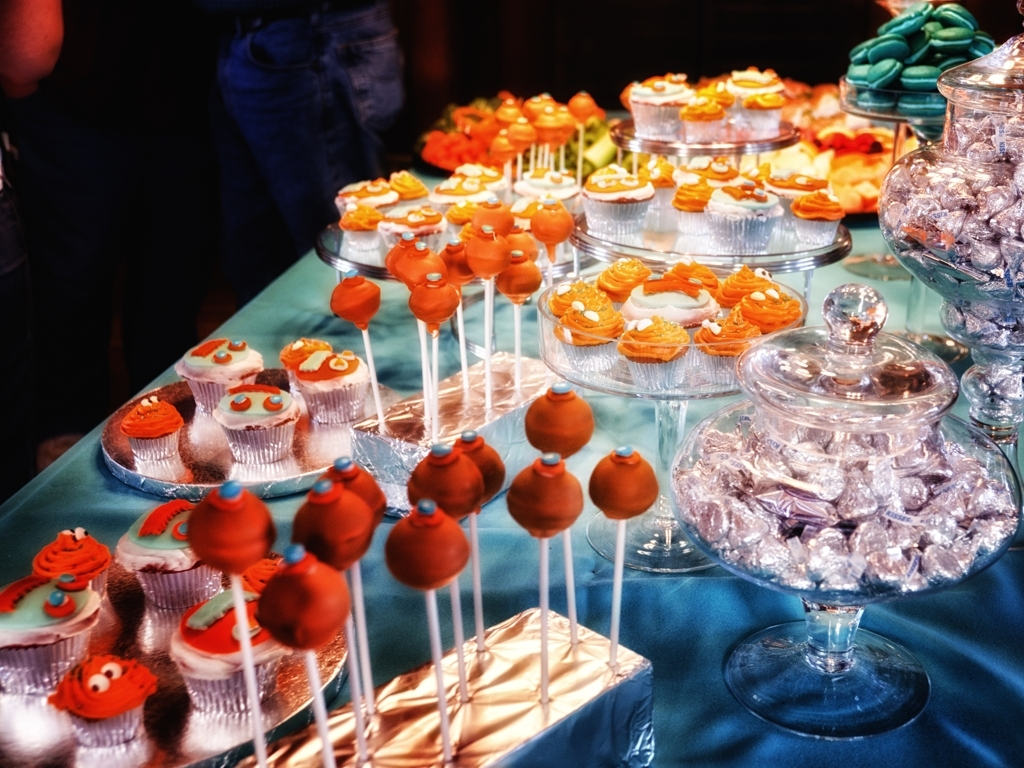What occasion might these treats be for? The display of festive cupcakes and cake pops, along with wrapped candies, suggests that these treats could be for a special celebration, possibly a birthday party, a holiday gathering, or a themed event. 